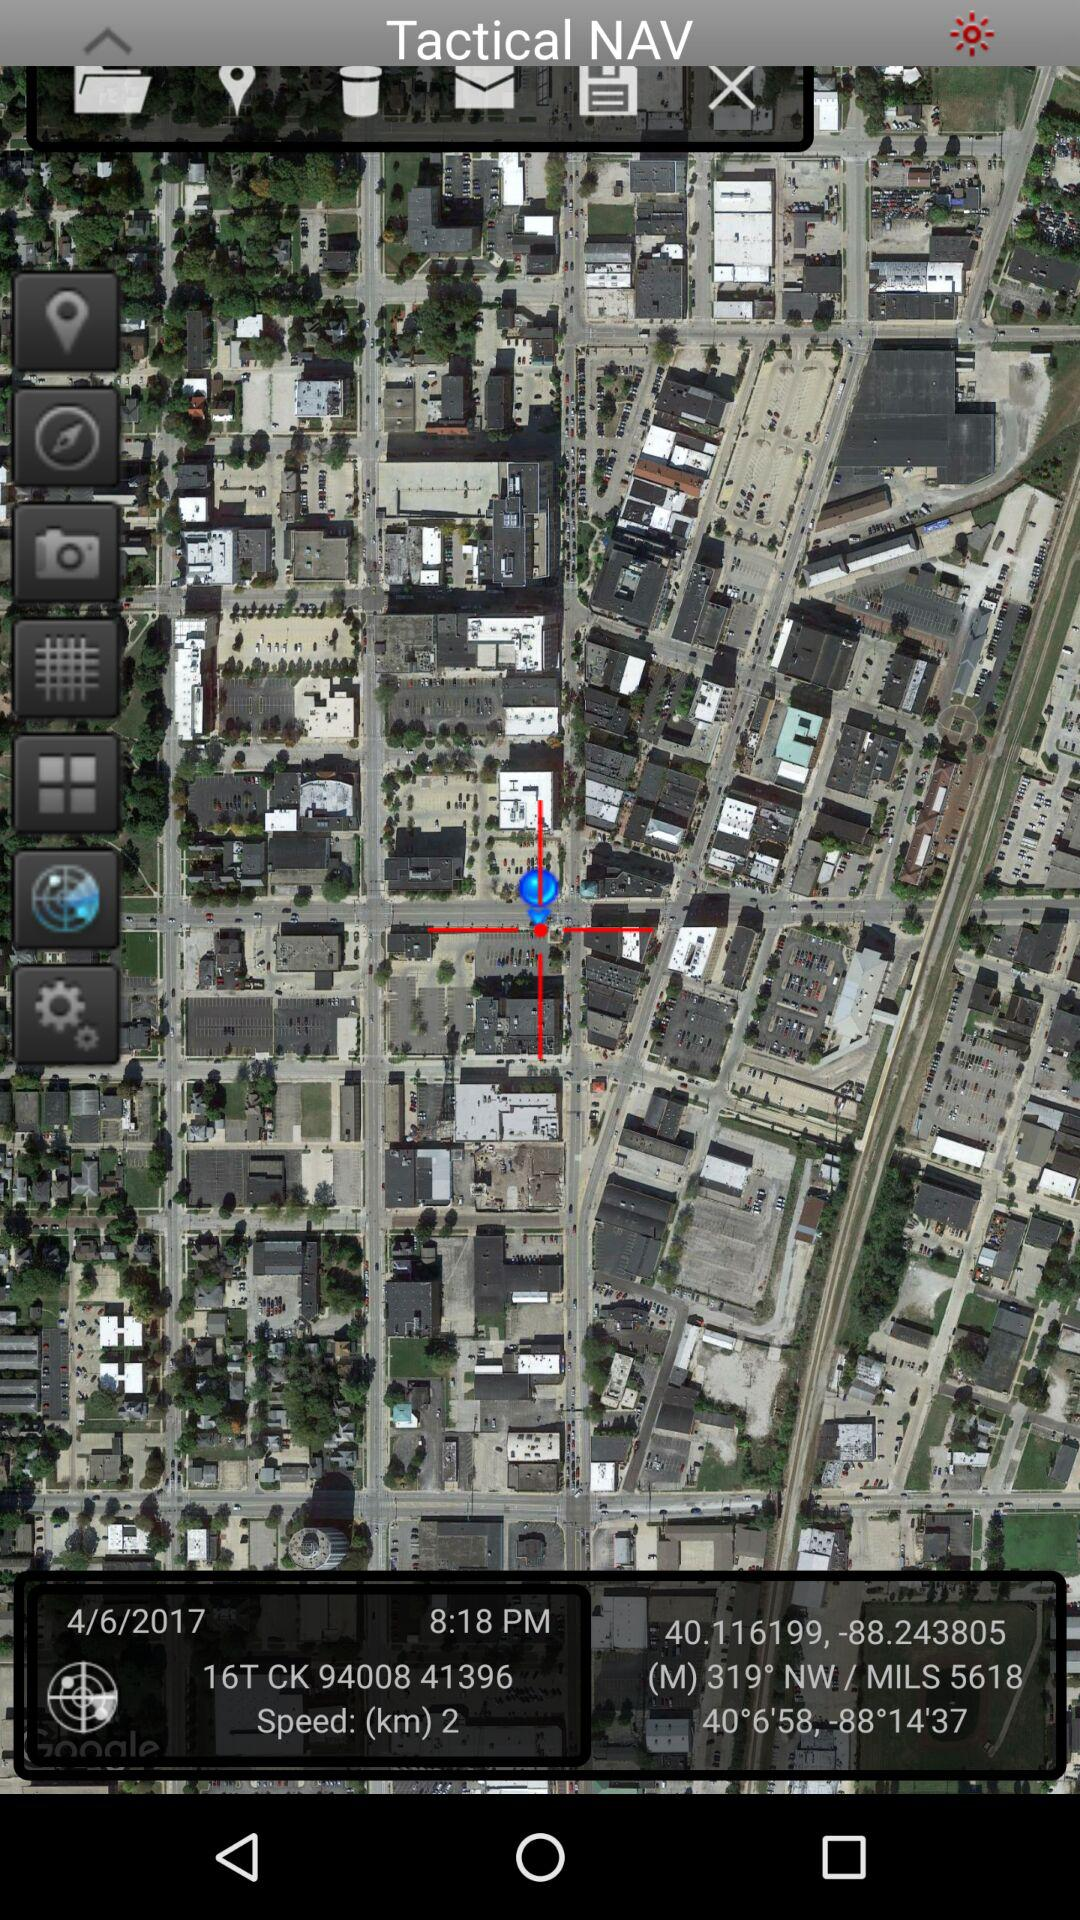What is the date and time? The date is June 4, 2017 and the time is 8:18 PM. 